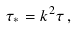Convert formula to latex. <formula><loc_0><loc_0><loc_500><loc_500>\tau _ { * } = k ^ { 2 } \tau \, ,</formula> 